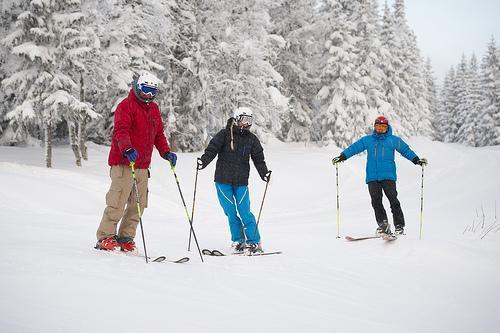How many people are on the snow?
Give a very brief answer. 3. 